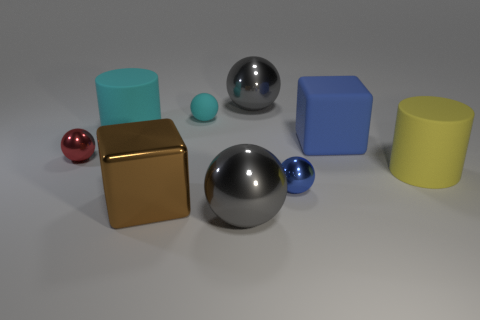Subtract all small red metallic spheres. How many spheres are left? 4 Subtract all red balls. How many balls are left? 4 Subtract all purple balls. Subtract all yellow blocks. How many balls are left? 5 Subtract all spheres. How many objects are left? 4 Subtract 0 purple balls. How many objects are left? 9 Subtract all matte cubes. Subtract all big rubber cubes. How many objects are left? 7 Add 2 rubber things. How many rubber things are left? 6 Add 1 big yellow cylinders. How many big yellow cylinders exist? 2 